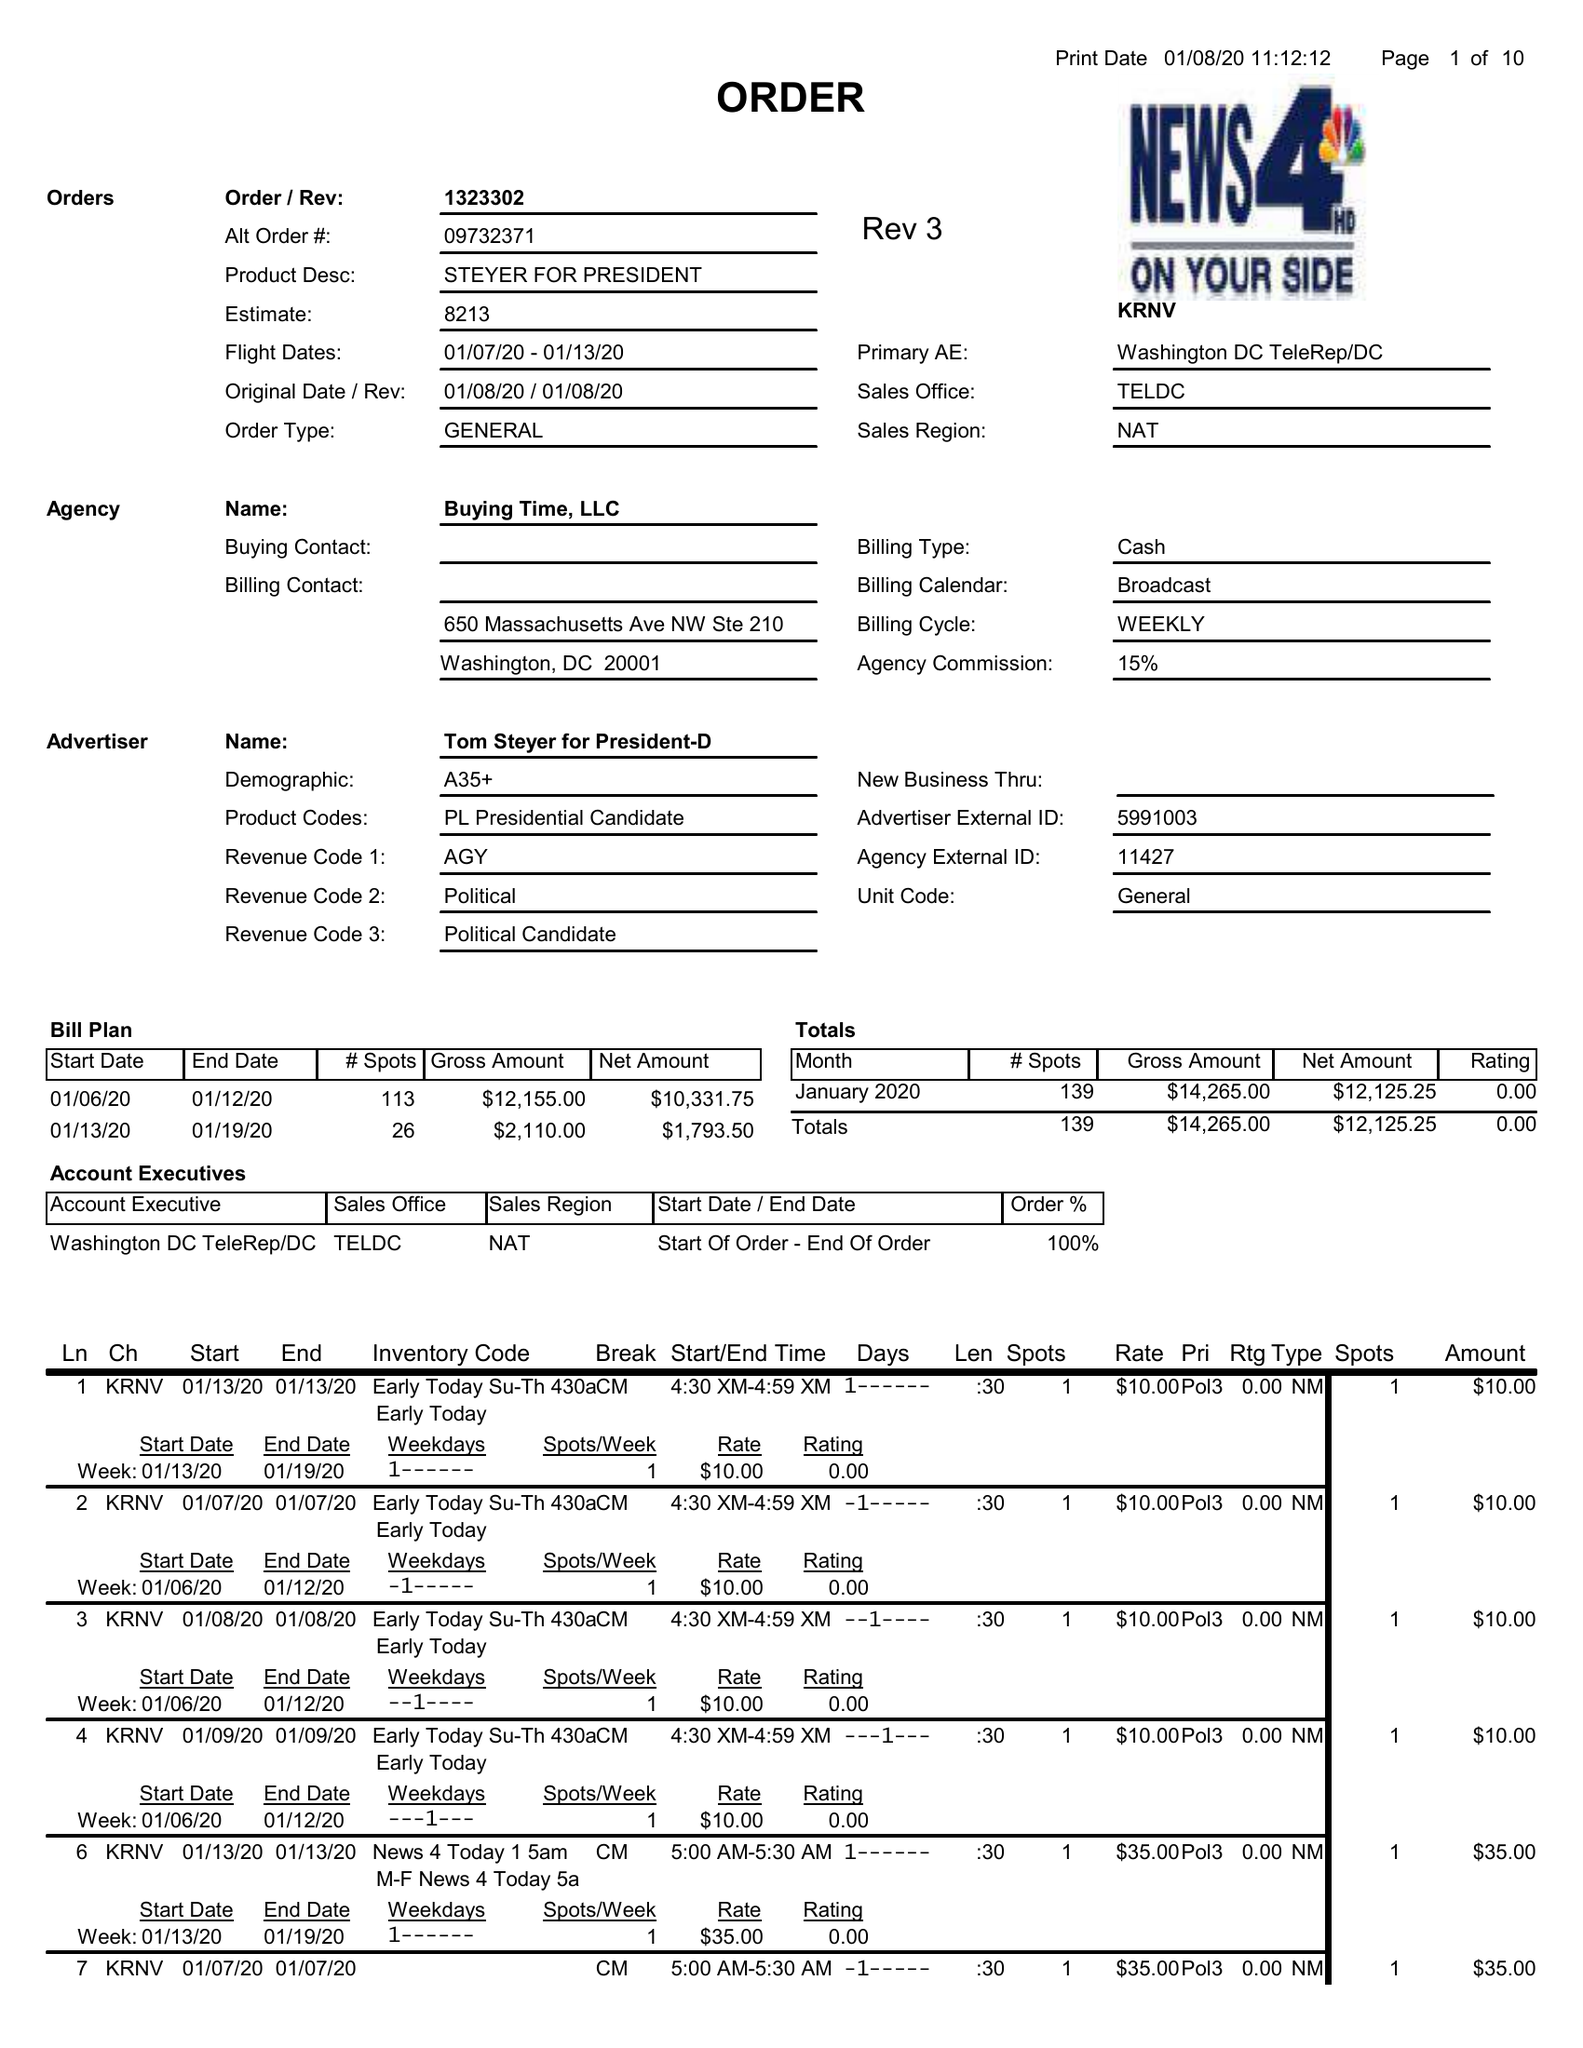What is the value for the gross_amount?
Answer the question using a single word or phrase. 14265.00 